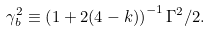Convert formula to latex. <formula><loc_0><loc_0><loc_500><loc_500>\gamma _ { b } ^ { 2 } \equiv \left ( 1 + 2 ( 4 - k ) \right ) ^ { - 1 } \Gamma ^ { 2 } / 2 .</formula> 